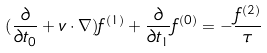<formula> <loc_0><loc_0><loc_500><loc_500>( \frac { \partial } { \partial t _ { 0 } } + { v } \cdot \nabla ) f ^ { ( 1 ) } + \frac { \partial } { \partial t _ { 1 } } f ^ { ( 0 ) } = - \frac { f ^ { ( 2 ) } } { \tau }</formula> 